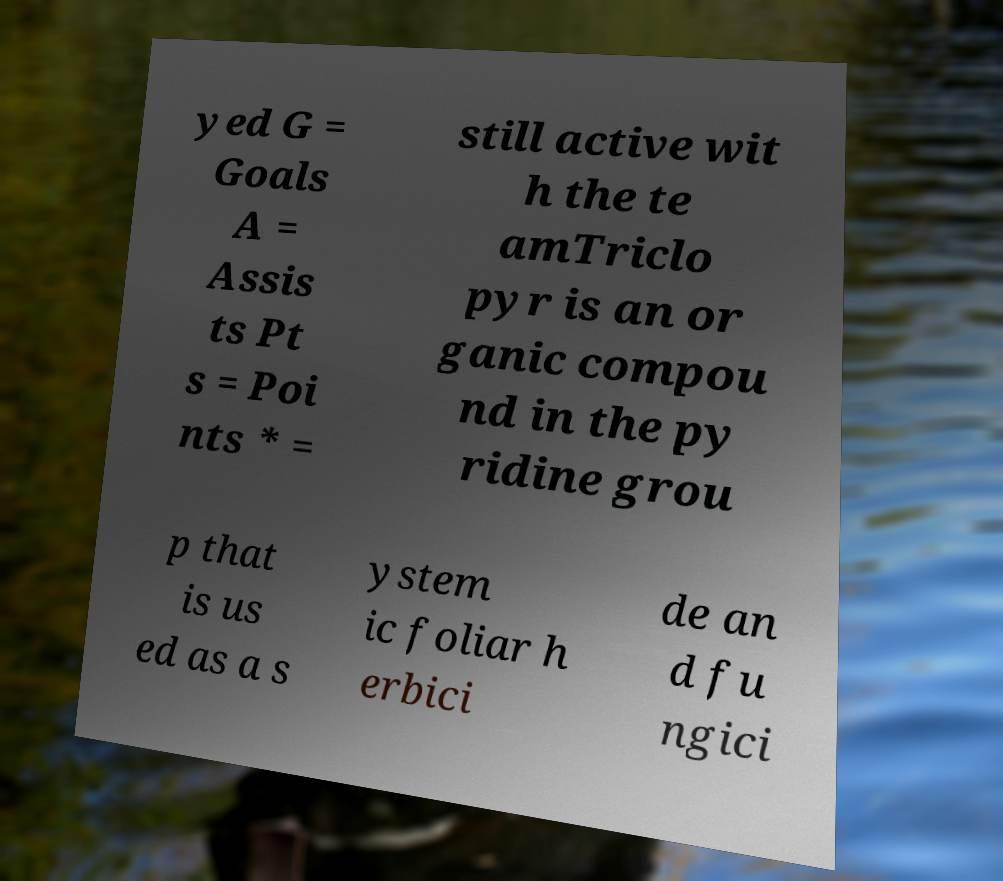Please identify and transcribe the text found in this image. yed G = Goals A = Assis ts Pt s = Poi nts * = still active wit h the te amTriclo pyr is an or ganic compou nd in the py ridine grou p that is us ed as a s ystem ic foliar h erbici de an d fu ngici 